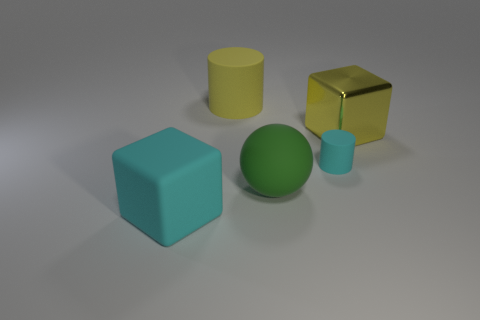Is the shiny block the same size as the rubber ball?
Keep it short and to the point. Yes. How many yellow objects are to the right of the yellow cylinder?
Your answer should be compact. 1. Is the number of small things that are in front of the yellow matte object the same as the number of large balls that are to the left of the big green rubber sphere?
Your response must be concise. No. Does the yellow object that is in front of the big cylinder have the same shape as the green thing?
Your answer should be very brief. No. Is there any other thing that has the same material as the big yellow cylinder?
Offer a very short reply. Yes. There is a cyan matte cylinder; does it have the same size as the matte thing in front of the rubber ball?
Keep it short and to the point. No. How many other objects are the same color as the big cylinder?
Make the answer very short. 1. Are there any large things on the right side of the rubber ball?
Ensure brevity in your answer.  Yes. How many objects are red objects or large yellow things behind the yellow metallic block?
Ensure brevity in your answer.  1. Are there any cyan cylinders that are right of the rubber thing behind the big yellow block?
Your answer should be very brief. Yes. 